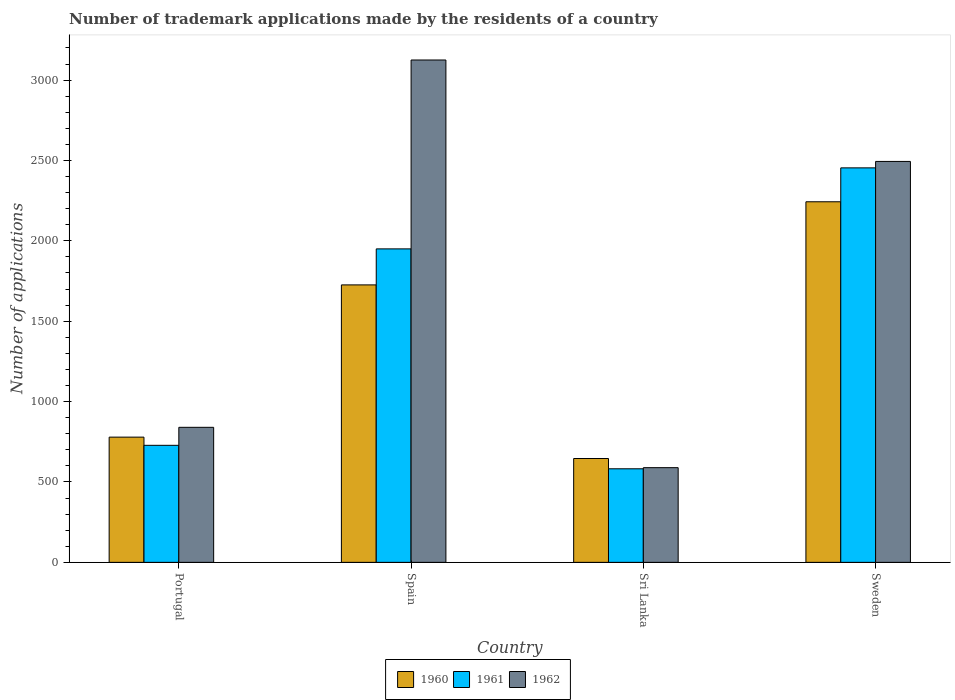Are the number of bars per tick equal to the number of legend labels?
Provide a succinct answer. Yes. Are the number of bars on each tick of the X-axis equal?
Keep it short and to the point. Yes. How many bars are there on the 4th tick from the left?
Keep it short and to the point. 3. What is the label of the 3rd group of bars from the left?
Your answer should be compact. Sri Lanka. In how many cases, is the number of bars for a given country not equal to the number of legend labels?
Make the answer very short. 0. What is the number of trademark applications made by the residents in 1960 in Sweden?
Offer a terse response. 2243. Across all countries, what is the maximum number of trademark applications made by the residents in 1962?
Ensure brevity in your answer.  3125. Across all countries, what is the minimum number of trademark applications made by the residents in 1962?
Provide a succinct answer. 589. In which country was the number of trademark applications made by the residents in 1962 minimum?
Make the answer very short. Sri Lanka. What is the total number of trademark applications made by the residents in 1960 in the graph?
Your answer should be very brief. 5394. What is the difference between the number of trademark applications made by the residents in 1961 in Portugal and that in Sri Lanka?
Make the answer very short. 146. What is the difference between the number of trademark applications made by the residents in 1962 in Spain and the number of trademark applications made by the residents in 1961 in Portugal?
Provide a succinct answer. 2397. What is the average number of trademark applications made by the residents in 1960 per country?
Your answer should be very brief. 1348.5. What is the difference between the number of trademark applications made by the residents of/in 1960 and number of trademark applications made by the residents of/in 1962 in Portugal?
Offer a terse response. -61. In how many countries, is the number of trademark applications made by the residents in 1962 greater than 800?
Provide a succinct answer. 3. What is the ratio of the number of trademark applications made by the residents in 1960 in Portugal to that in Sri Lanka?
Your answer should be compact. 1.21. Is the number of trademark applications made by the residents in 1961 in Portugal less than that in Sweden?
Give a very brief answer. Yes. Is the difference between the number of trademark applications made by the residents in 1960 in Spain and Sri Lanka greater than the difference between the number of trademark applications made by the residents in 1962 in Spain and Sri Lanka?
Ensure brevity in your answer.  No. What is the difference between the highest and the second highest number of trademark applications made by the residents in 1961?
Give a very brief answer. -1222. What is the difference between the highest and the lowest number of trademark applications made by the residents in 1962?
Provide a succinct answer. 2536. Is it the case that in every country, the sum of the number of trademark applications made by the residents in 1960 and number of trademark applications made by the residents in 1961 is greater than the number of trademark applications made by the residents in 1962?
Your response must be concise. Yes. Are all the bars in the graph horizontal?
Keep it short and to the point. No. What is the difference between two consecutive major ticks on the Y-axis?
Keep it short and to the point. 500. Are the values on the major ticks of Y-axis written in scientific E-notation?
Keep it short and to the point. No. Where does the legend appear in the graph?
Offer a terse response. Bottom center. How many legend labels are there?
Your response must be concise. 3. How are the legend labels stacked?
Your answer should be very brief. Horizontal. What is the title of the graph?
Your answer should be compact. Number of trademark applications made by the residents of a country. Does "1969" appear as one of the legend labels in the graph?
Make the answer very short. No. What is the label or title of the X-axis?
Your response must be concise. Country. What is the label or title of the Y-axis?
Give a very brief answer. Number of applications. What is the Number of applications in 1960 in Portugal?
Ensure brevity in your answer.  779. What is the Number of applications in 1961 in Portugal?
Your response must be concise. 728. What is the Number of applications of 1962 in Portugal?
Ensure brevity in your answer.  840. What is the Number of applications of 1960 in Spain?
Offer a very short reply. 1726. What is the Number of applications in 1961 in Spain?
Keep it short and to the point. 1950. What is the Number of applications of 1962 in Spain?
Your response must be concise. 3125. What is the Number of applications of 1960 in Sri Lanka?
Make the answer very short. 646. What is the Number of applications of 1961 in Sri Lanka?
Ensure brevity in your answer.  582. What is the Number of applications in 1962 in Sri Lanka?
Your answer should be compact. 589. What is the Number of applications in 1960 in Sweden?
Offer a terse response. 2243. What is the Number of applications of 1961 in Sweden?
Your response must be concise. 2454. What is the Number of applications of 1962 in Sweden?
Provide a short and direct response. 2494. Across all countries, what is the maximum Number of applications in 1960?
Give a very brief answer. 2243. Across all countries, what is the maximum Number of applications of 1961?
Make the answer very short. 2454. Across all countries, what is the maximum Number of applications in 1962?
Keep it short and to the point. 3125. Across all countries, what is the minimum Number of applications of 1960?
Make the answer very short. 646. Across all countries, what is the minimum Number of applications of 1961?
Offer a very short reply. 582. Across all countries, what is the minimum Number of applications in 1962?
Your answer should be compact. 589. What is the total Number of applications in 1960 in the graph?
Your answer should be compact. 5394. What is the total Number of applications of 1961 in the graph?
Give a very brief answer. 5714. What is the total Number of applications in 1962 in the graph?
Provide a succinct answer. 7048. What is the difference between the Number of applications of 1960 in Portugal and that in Spain?
Make the answer very short. -947. What is the difference between the Number of applications of 1961 in Portugal and that in Spain?
Make the answer very short. -1222. What is the difference between the Number of applications of 1962 in Portugal and that in Spain?
Your response must be concise. -2285. What is the difference between the Number of applications in 1960 in Portugal and that in Sri Lanka?
Offer a terse response. 133. What is the difference between the Number of applications in 1961 in Portugal and that in Sri Lanka?
Your answer should be compact. 146. What is the difference between the Number of applications of 1962 in Portugal and that in Sri Lanka?
Give a very brief answer. 251. What is the difference between the Number of applications of 1960 in Portugal and that in Sweden?
Give a very brief answer. -1464. What is the difference between the Number of applications in 1961 in Portugal and that in Sweden?
Keep it short and to the point. -1726. What is the difference between the Number of applications of 1962 in Portugal and that in Sweden?
Ensure brevity in your answer.  -1654. What is the difference between the Number of applications in 1960 in Spain and that in Sri Lanka?
Your answer should be very brief. 1080. What is the difference between the Number of applications in 1961 in Spain and that in Sri Lanka?
Give a very brief answer. 1368. What is the difference between the Number of applications of 1962 in Spain and that in Sri Lanka?
Offer a terse response. 2536. What is the difference between the Number of applications of 1960 in Spain and that in Sweden?
Provide a short and direct response. -517. What is the difference between the Number of applications in 1961 in Spain and that in Sweden?
Provide a short and direct response. -504. What is the difference between the Number of applications of 1962 in Spain and that in Sweden?
Provide a short and direct response. 631. What is the difference between the Number of applications in 1960 in Sri Lanka and that in Sweden?
Ensure brevity in your answer.  -1597. What is the difference between the Number of applications of 1961 in Sri Lanka and that in Sweden?
Make the answer very short. -1872. What is the difference between the Number of applications in 1962 in Sri Lanka and that in Sweden?
Your answer should be very brief. -1905. What is the difference between the Number of applications in 1960 in Portugal and the Number of applications in 1961 in Spain?
Offer a very short reply. -1171. What is the difference between the Number of applications in 1960 in Portugal and the Number of applications in 1962 in Spain?
Keep it short and to the point. -2346. What is the difference between the Number of applications of 1961 in Portugal and the Number of applications of 1962 in Spain?
Ensure brevity in your answer.  -2397. What is the difference between the Number of applications of 1960 in Portugal and the Number of applications of 1961 in Sri Lanka?
Provide a succinct answer. 197. What is the difference between the Number of applications of 1960 in Portugal and the Number of applications of 1962 in Sri Lanka?
Your response must be concise. 190. What is the difference between the Number of applications of 1961 in Portugal and the Number of applications of 1962 in Sri Lanka?
Give a very brief answer. 139. What is the difference between the Number of applications in 1960 in Portugal and the Number of applications in 1961 in Sweden?
Provide a succinct answer. -1675. What is the difference between the Number of applications in 1960 in Portugal and the Number of applications in 1962 in Sweden?
Keep it short and to the point. -1715. What is the difference between the Number of applications in 1961 in Portugal and the Number of applications in 1962 in Sweden?
Provide a short and direct response. -1766. What is the difference between the Number of applications in 1960 in Spain and the Number of applications in 1961 in Sri Lanka?
Your answer should be very brief. 1144. What is the difference between the Number of applications of 1960 in Spain and the Number of applications of 1962 in Sri Lanka?
Your response must be concise. 1137. What is the difference between the Number of applications of 1961 in Spain and the Number of applications of 1962 in Sri Lanka?
Your response must be concise. 1361. What is the difference between the Number of applications of 1960 in Spain and the Number of applications of 1961 in Sweden?
Give a very brief answer. -728. What is the difference between the Number of applications of 1960 in Spain and the Number of applications of 1962 in Sweden?
Your response must be concise. -768. What is the difference between the Number of applications of 1961 in Spain and the Number of applications of 1962 in Sweden?
Offer a terse response. -544. What is the difference between the Number of applications of 1960 in Sri Lanka and the Number of applications of 1961 in Sweden?
Your response must be concise. -1808. What is the difference between the Number of applications in 1960 in Sri Lanka and the Number of applications in 1962 in Sweden?
Offer a very short reply. -1848. What is the difference between the Number of applications in 1961 in Sri Lanka and the Number of applications in 1962 in Sweden?
Provide a succinct answer. -1912. What is the average Number of applications of 1960 per country?
Offer a very short reply. 1348.5. What is the average Number of applications of 1961 per country?
Keep it short and to the point. 1428.5. What is the average Number of applications of 1962 per country?
Offer a very short reply. 1762. What is the difference between the Number of applications of 1960 and Number of applications of 1962 in Portugal?
Provide a short and direct response. -61. What is the difference between the Number of applications of 1961 and Number of applications of 1962 in Portugal?
Ensure brevity in your answer.  -112. What is the difference between the Number of applications of 1960 and Number of applications of 1961 in Spain?
Your answer should be compact. -224. What is the difference between the Number of applications of 1960 and Number of applications of 1962 in Spain?
Your response must be concise. -1399. What is the difference between the Number of applications of 1961 and Number of applications of 1962 in Spain?
Provide a succinct answer. -1175. What is the difference between the Number of applications in 1961 and Number of applications in 1962 in Sri Lanka?
Provide a succinct answer. -7. What is the difference between the Number of applications in 1960 and Number of applications in 1961 in Sweden?
Provide a succinct answer. -211. What is the difference between the Number of applications of 1960 and Number of applications of 1962 in Sweden?
Your answer should be very brief. -251. What is the difference between the Number of applications in 1961 and Number of applications in 1962 in Sweden?
Keep it short and to the point. -40. What is the ratio of the Number of applications of 1960 in Portugal to that in Spain?
Your response must be concise. 0.45. What is the ratio of the Number of applications in 1961 in Portugal to that in Spain?
Provide a succinct answer. 0.37. What is the ratio of the Number of applications in 1962 in Portugal to that in Spain?
Provide a short and direct response. 0.27. What is the ratio of the Number of applications of 1960 in Portugal to that in Sri Lanka?
Keep it short and to the point. 1.21. What is the ratio of the Number of applications in 1961 in Portugal to that in Sri Lanka?
Ensure brevity in your answer.  1.25. What is the ratio of the Number of applications of 1962 in Portugal to that in Sri Lanka?
Provide a succinct answer. 1.43. What is the ratio of the Number of applications in 1960 in Portugal to that in Sweden?
Your answer should be very brief. 0.35. What is the ratio of the Number of applications in 1961 in Portugal to that in Sweden?
Provide a succinct answer. 0.3. What is the ratio of the Number of applications in 1962 in Portugal to that in Sweden?
Ensure brevity in your answer.  0.34. What is the ratio of the Number of applications in 1960 in Spain to that in Sri Lanka?
Give a very brief answer. 2.67. What is the ratio of the Number of applications of 1961 in Spain to that in Sri Lanka?
Offer a terse response. 3.35. What is the ratio of the Number of applications of 1962 in Spain to that in Sri Lanka?
Your response must be concise. 5.31. What is the ratio of the Number of applications of 1960 in Spain to that in Sweden?
Give a very brief answer. 0.77. What is the ratio of the Number of applications of 1961 in Spain to that in Sweden?
Ensure brevity in your answer.  0.79. What is the ratio of the Number of applications in 1962 in Spain to that in Sweden?
Provide a succinct answer. 1.25. What is the ratio of the Number of applications of 1960 in Sri Lanka to that in Sweden?
Ensure brevity in your answer.  0.29. What is the ratio of the Number of applications in 1961 in Sri Lanka to that in Sweden?
Keep it short and to the point. 0.24. What is the ratio of the Number of applications of 1962 in Sri Lanka to that in Sweden?
Ensure brevity in your answer.  0.24. What is the difference between the highest and the second highest Number of applications in 1960?
Provide a short and direct response. 517. What is the difference between the highest and the second highest Number of applications of 1961?
Provide a short and direct response. 504. What is the difference between the highest and the second highest Number of applications of 1962?
Give a very brief answer. 631. What is the difference between the highest and the lowest Number of applications of 1960?
Your answer should be very brief. 1597. What is the difference between the highest and the lowest Number of applications in 1961?
Your response must be concise. 1872. What is the difference between the highest and the lowest Number of applications in 1962?
Your answer should be compact. 2536. 